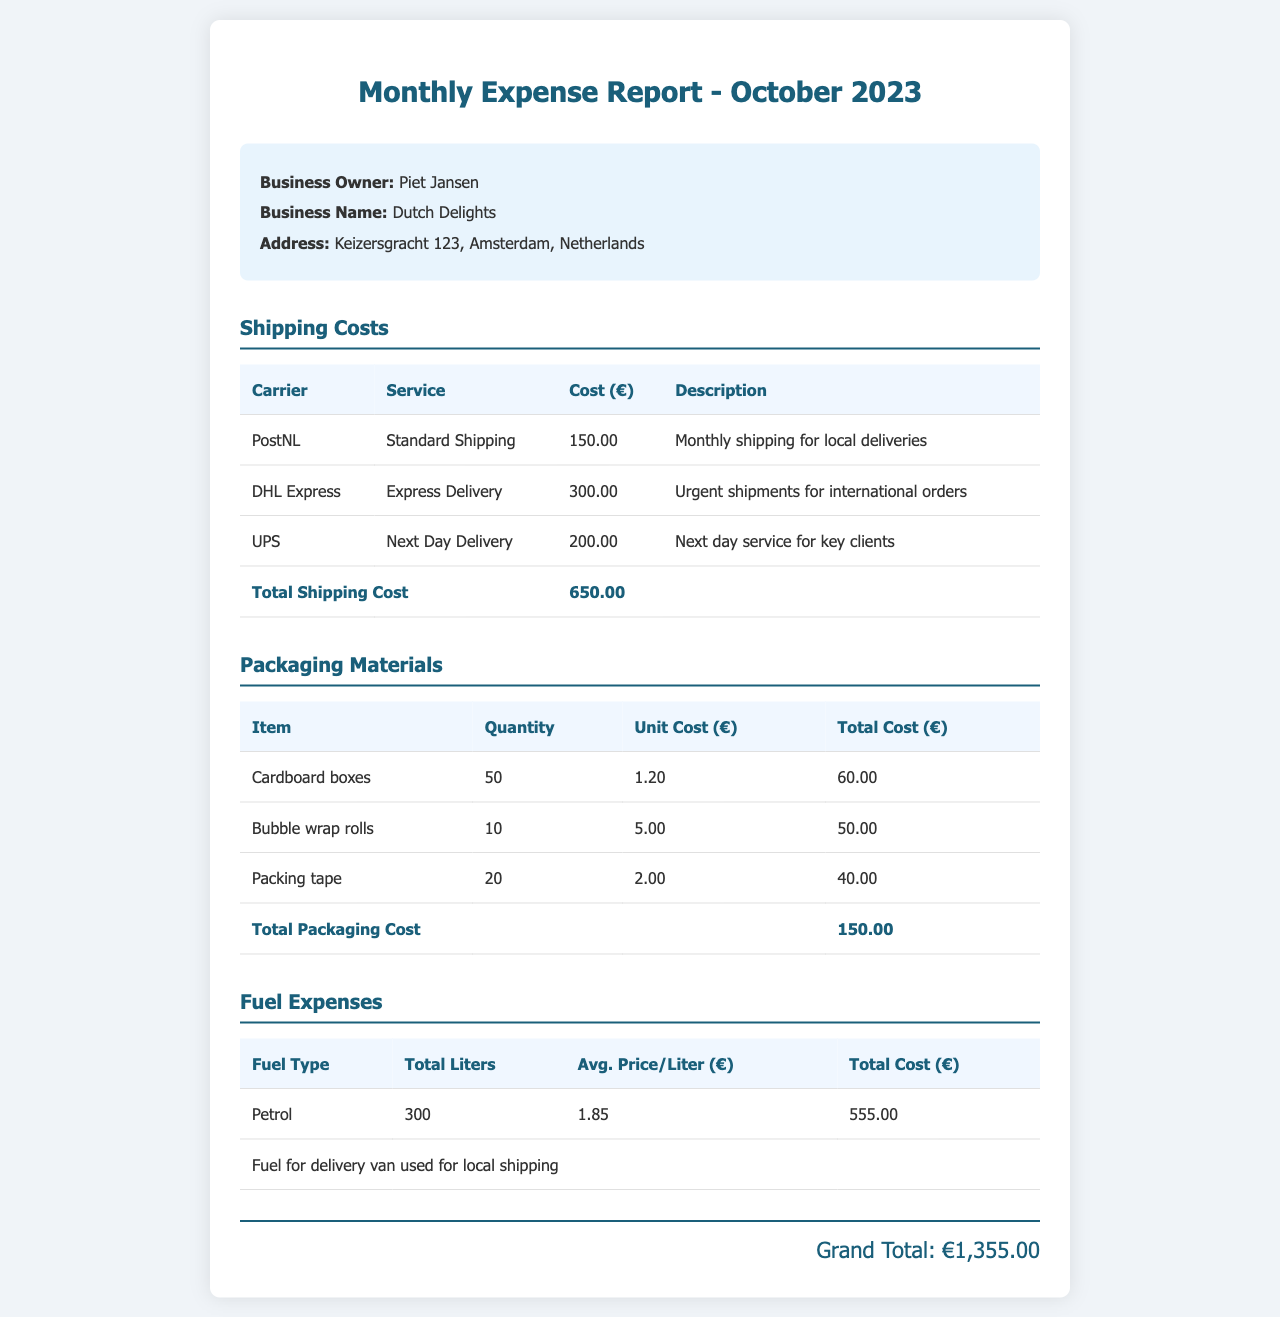What is the business owner's name? The document clearly states the name of the business owner, which is mentioned in the header section.
Answer: Piet Jansen What is the total cost of shipping? The total cost for all shipping services is provided in the shipping costs section as a summary.
Answer: 650.00 How many cardboard boxes were purchased? The quantity of cardboard boxes is listed in the packaging materials section.
Answer: 50 What was the average price per liter of petrol? The average price per liter for petrol is mentioned in the fuel expenses section.
Answer: 1.85 What is the grand total of all expenses? The grand total is calculated and presented at the end of the document.
Answer: 1,355.00 How much did DHL Express charge for their service? The cost charged by DHL Express is specified in the shipping costs table.
Answer: 300.00 What is the total cost for packing tape? The total cost for packing tape is detailed in the packaging materials table.
Answer: 40.00 What type of fuel is used for the delivery van? The type of fuel mentioned for the delivery van is provided in the fuel expenses table.
Answer: Petrol What is the address of the business? The address of the business is listed in the header section of the document.
Answer: Keizersgracht 123, Amsterdam, Netherlands 